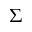Convert formula to latex. <formula><loc_0><loc_0><loc_500><loc_500>\Sigma</formula> 